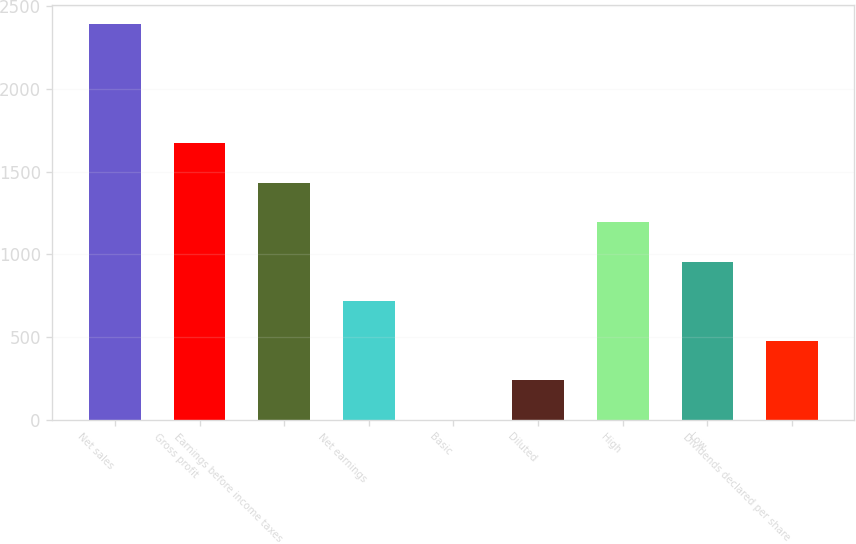Convert chart to OTSL. <chart><loc_0><loc_0><loc_500><loc_500><bar_chart><fcel>Net sales<fcel>Gross profit<fcel>Earnings before income taxes<fcel>Net earnings<fcel>Basic<fcel>Diluted<fcel>High<fcel>Low<fcel>Dividends declared per share<nl><fcel>2389<fcel>1672.32<fcel>1433.44<fcel>716.8<fcel>0.16<fcel>239.04<fcel>1194.56<fcel>955.68<fcel>477.92<nl></chart> 